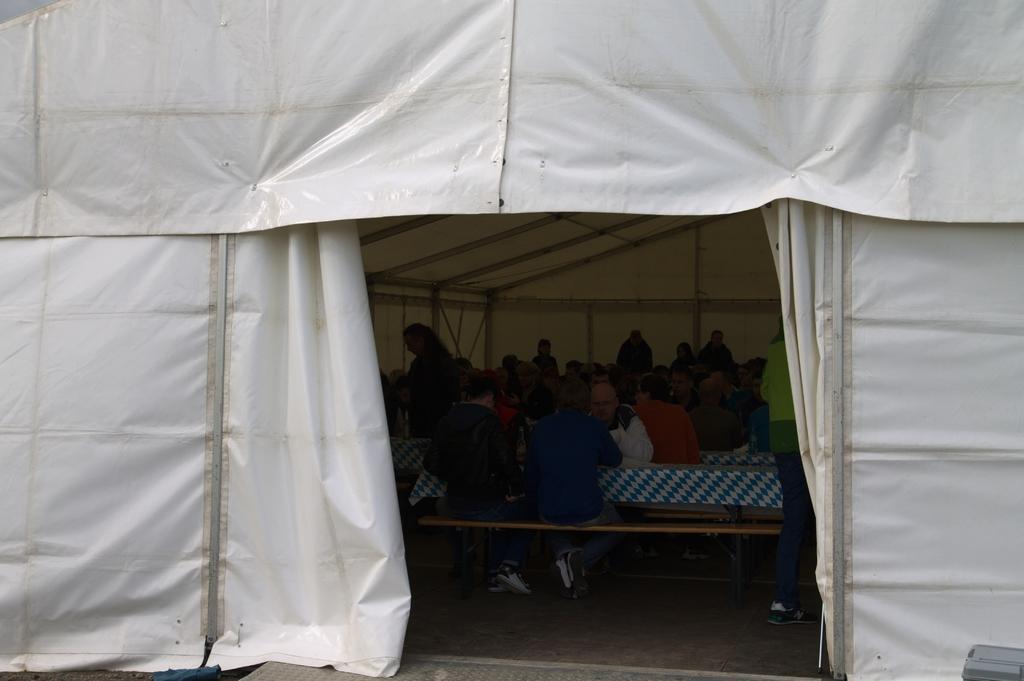Could you give a brief overview of what you see in this image? In this image there are some persons sitting on the benches as we can see in middle of this image and there is a tent which is in white color as we can see at top of this image. 